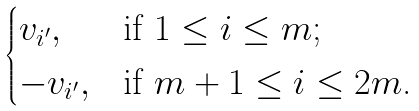Convert formula to latex. <formula><loc_0><loc_0><loc_500><loc_500>\begin{cases} v _ { i ^ { \prime } } , & \text {if $1\leq i\leq m$;} \\ - v _ { i ^ { \prime } } , & \text {if $m+1\leq i\leq 2m$.} \end{cases}</formula> 